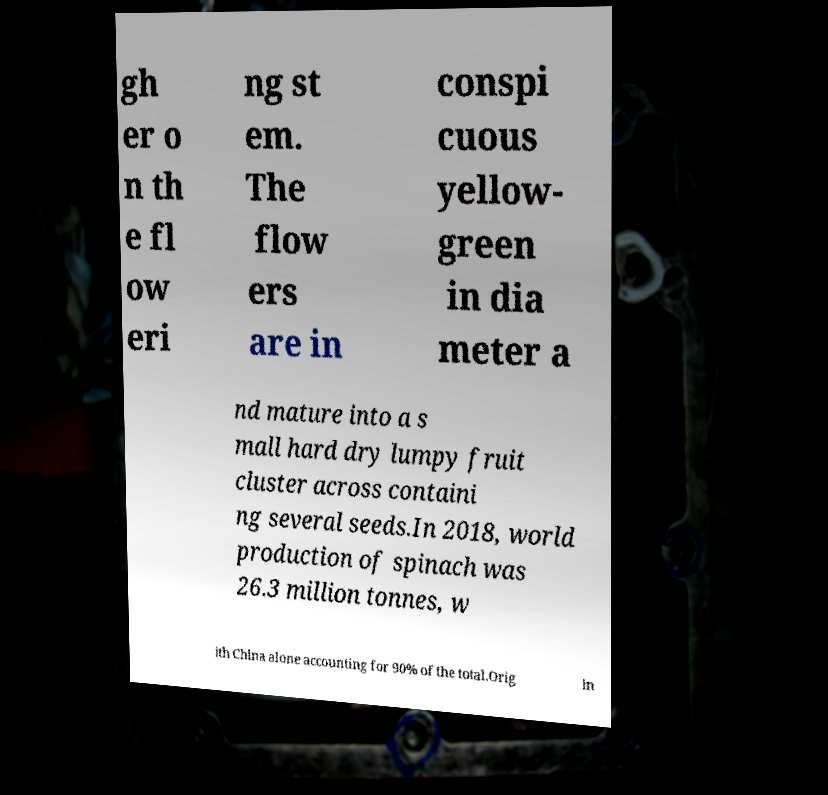Could you extract and type out the text from this image? gh er o n th e fl ow eri ng st em. The flow ers are in conspi cuous yellow- green in dia meter a nd mature into a s mall hard dry lumpy fruit cluster across containi ng several seeds.In 2018, world production of spinach was 26.3 million tonnes, w ith China alone accounting for 90% of the total.Orig in 